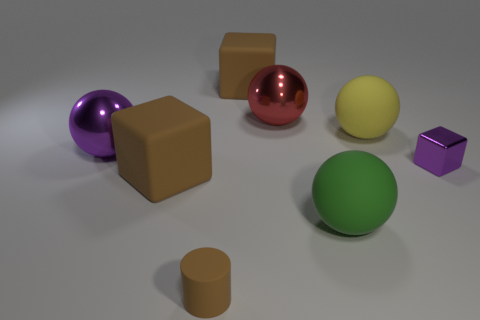How do the objects interact with the light source? The objects with shiny surfaces, such as the purple, red, and brown cube, reflect the light, giving them a gleaming appearance and casting distinct, sharp-edged shadows. The objects with matte surfaces, like the yellow and green spheres, scatter light more evenly and create softer-edged shadows, demonstrating differences in texture and material properties. 